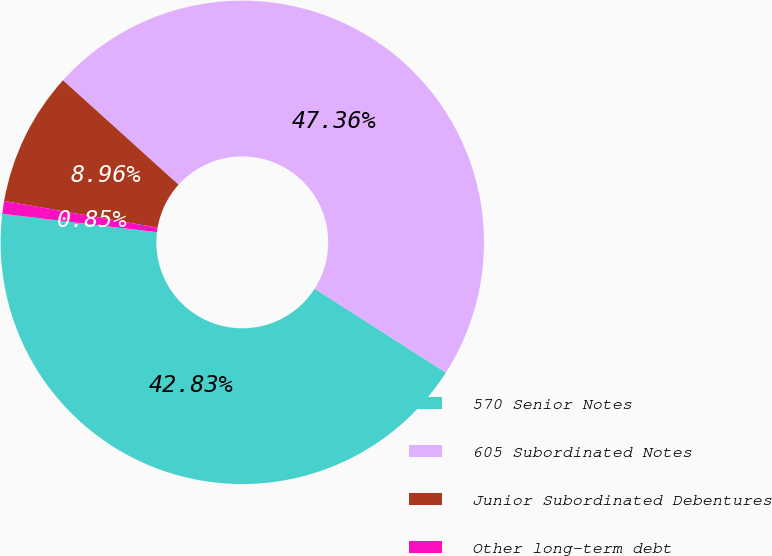Convert chart to OTSL. <chart><loc_0><loc_0><loc_500><loc_500><pie_chart><fcel>570 Senior Notes<fcel>605 Subordinated Notes<fcel>Junior Subordinated Debentures<fcel>Other long-term debt<nl><fcel>42.83%<fcel>47.36%<fcel>8.96%<fcel>0.85%<nl></chart> 